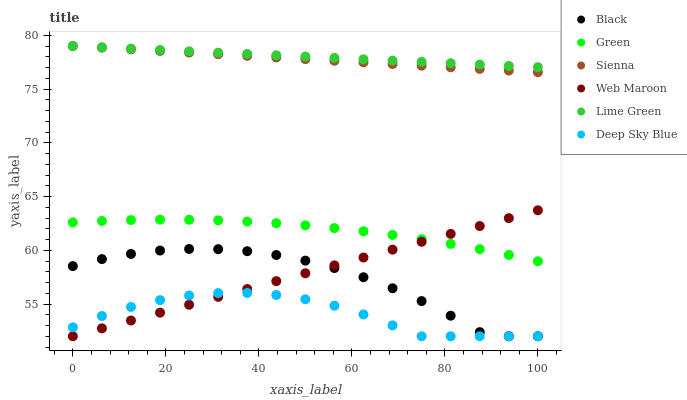Does Deep Sky Blue have the minimum area under the curve?
Answer yes or no. Yes. Does Lime Green have the maximum area under the curve?
Answer yes or no. Yes. Does Sienna have the minimum area under the curve?
Answer yes or no. No. Does Sienna have the maximum area under the curve?
Answer yes or no. No. Is Sienna the smoothest?
Answer yes or no. Yes. Is Black the roughest?
Answer yes or no. Yes. Is Green the smoothest?
Answer yes or no. No. Is Green the roughest?
Answer yes or no. No. Does Web Maroon have the lowest value?
Answer yes or no. Yes. Does Sienna have the lowest value?
Answer yes or no. No. Does Lime Green have the highest value?
Answer yes or no. Yes. Does Green have the highest value?
Answer yes or no. No. Is Black less than Green?
Answer yes or no. Yes. Is Sienna greater than Green?
Answer yes or no. Yes. Does Web Maroon intersect Deep Sky Blue?
Answer yes or no. Yes. Is Web Maroon less than Deep Sky Blue?
Answer yes or no. No. Is Web Maroon greater than Deep Sky Blue?
Answer yes or no. No. Does Black intersect Green?
Answer yes or no. No. 